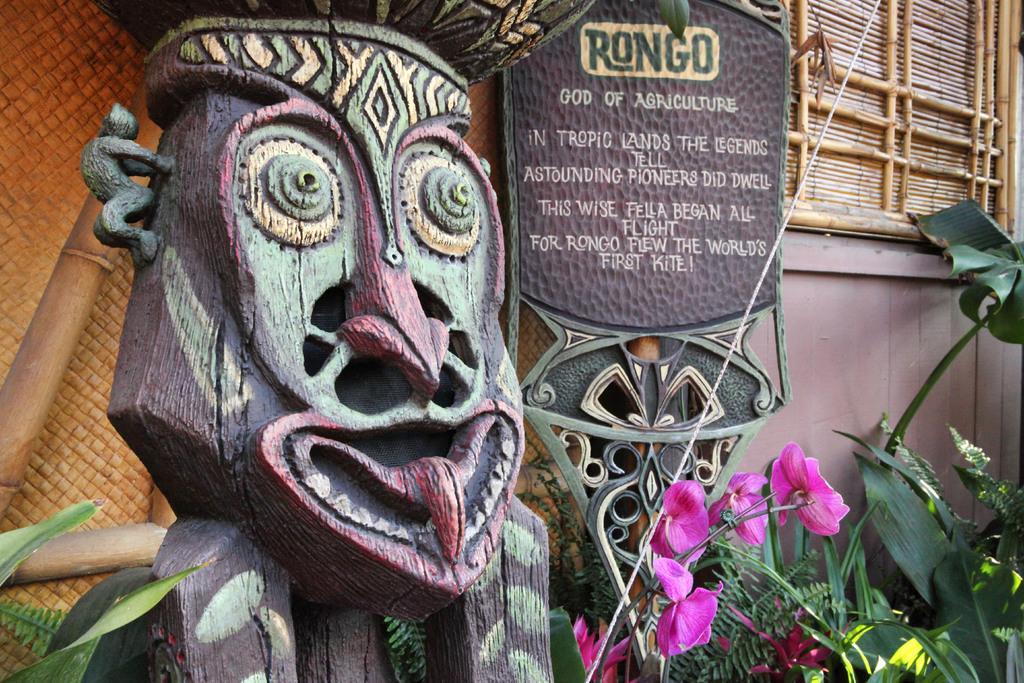Could you give a brief overview of what you see in this image? In the picture we can see a wooden sculpture and beside it, we can see a board written something on it and near it, we can see some plants and flowers to it and behind it we can see a wall. 